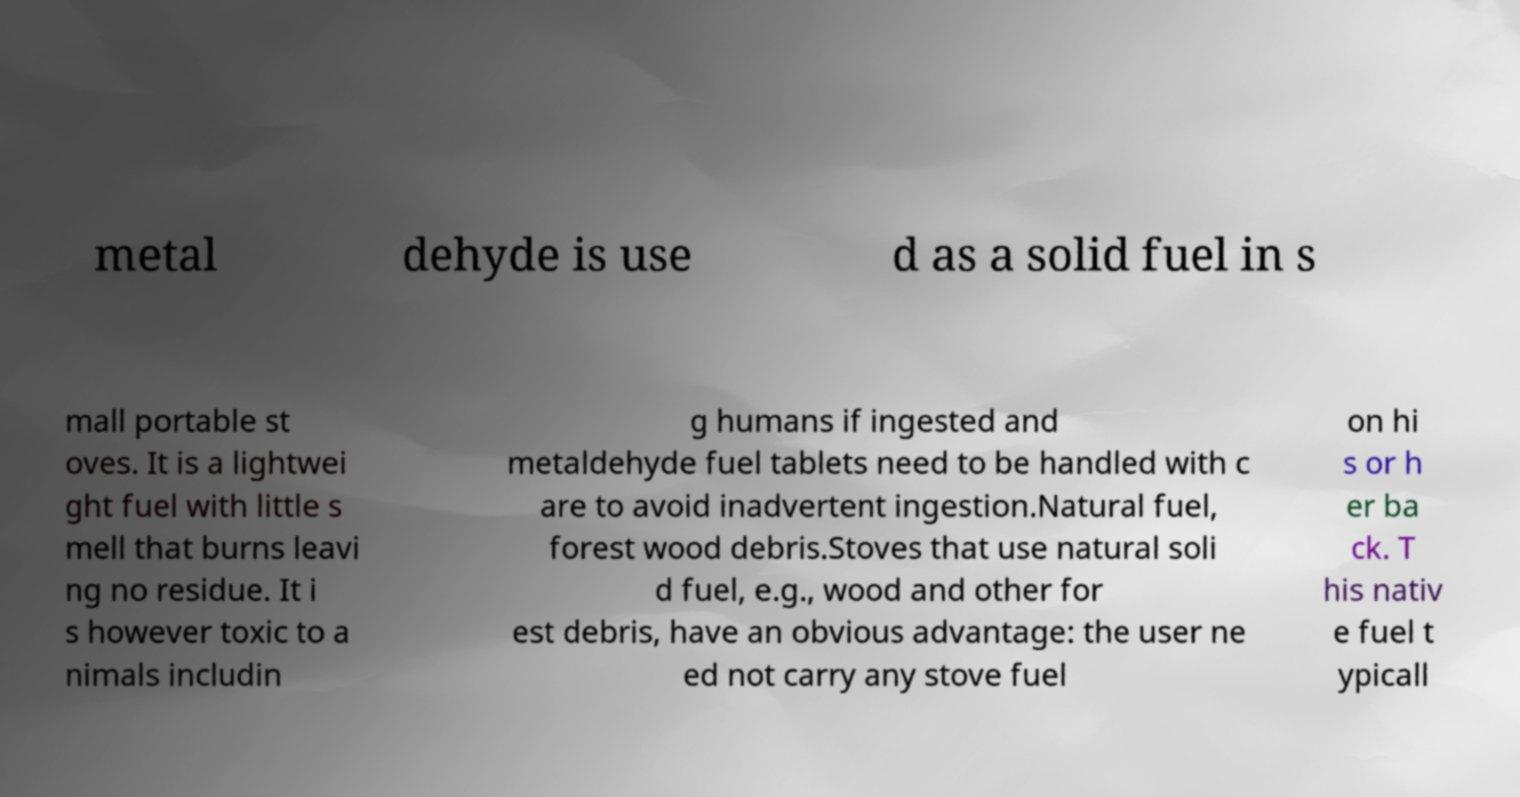Can you accurately transcribe the text from the provided image for me? metal dehyde is use d as a solid fuel in s mall portable st oves. It is a lightwei ght fuel with little s mell that burns leavi ng no residue. It i s however toxic to a nimals includin g humans if ingested and metaldehyde fuel tablets need to be handled with c are to avoid inadvertent ingestion.Natural fuel, forest wood debris.Stoves that use natural soli d fuel, e.g., wood and other for est debris, have an obvious advantage: the user ne ed not carry any stove fuel on hi s or h er ba ck. T his nativ e fuel t ypicall 